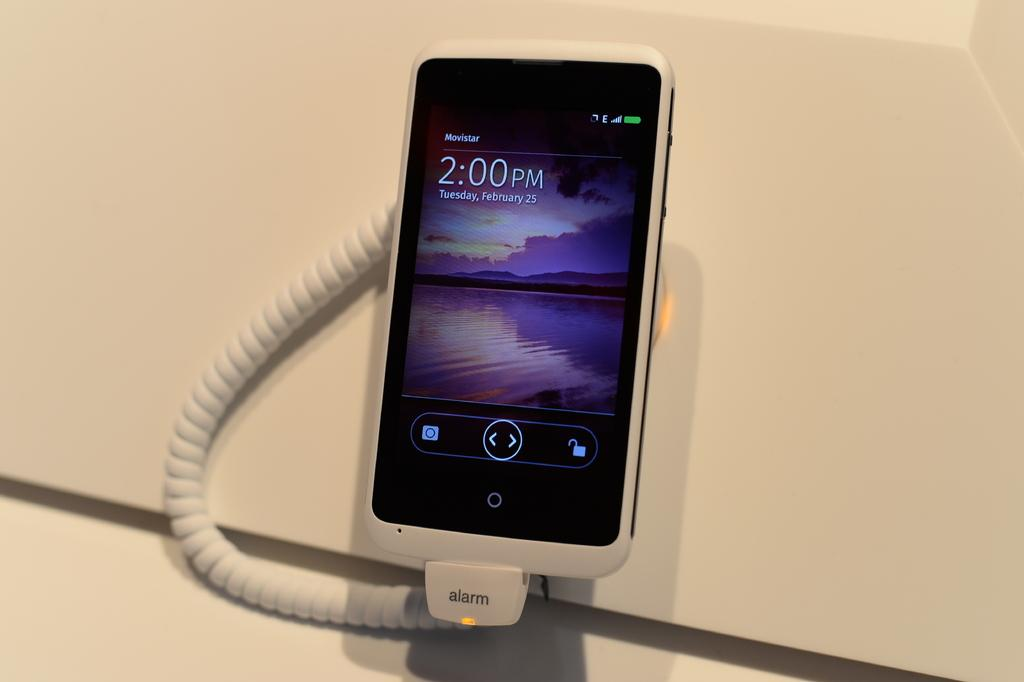<image>
Share a concise interpretation of the image provided. Screen of a phone that shows the current time at 2:00. 